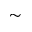<formula> <loc_0><loc_0><loc_500><loc_500>\sim</formula> 